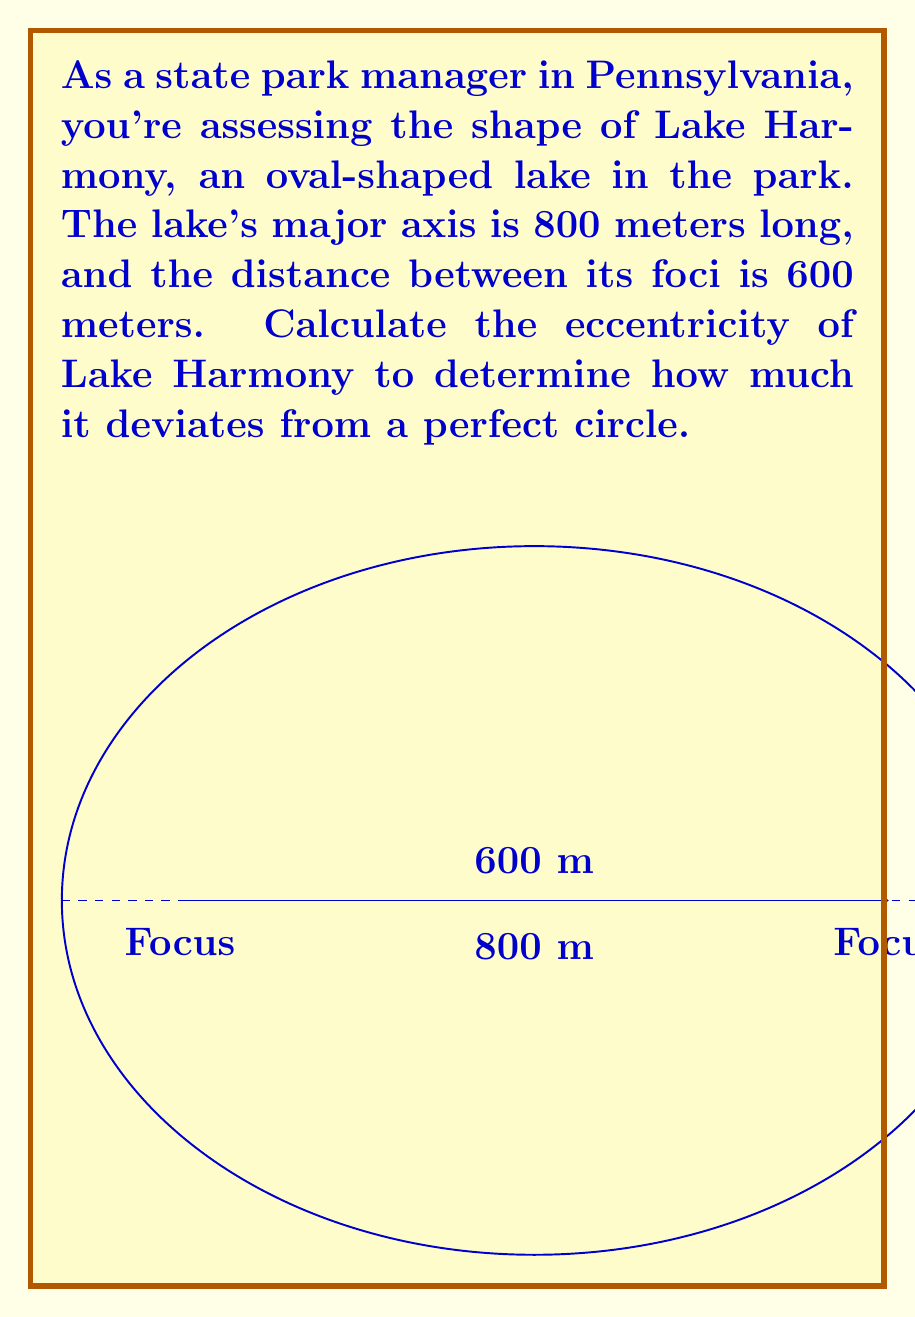What is the answer to this math problem? To find the eccentricity of the oval-shaped lake, we'll follow these steps:

1) The eccentricity (e) of an ellipse is defined as the ratio of the distance between the foci (c) to the length of the semi-major axis (a):

   $$ e = \frac{c}{a} $$

2) We're given:
   - Major axis length = 800 meters
   - Distance between foci = 600 meters

3) The semi-major axis (a) is half of the major axis:
   $$ a = \frac{800}{2} = 400 \text{ meters} $$

4) The distance from the center to a focus (c) is half of the distance between foci:
   $$ c = \frac{600}{2} = 300 \text{ meters} $$

5) Now we can calculate the eccentricity:
   $$ e = \frac{c}{a} = \frac{300}{400} = 0.75 $$

6) The eccentricity is always a value between 0 and 1 for an ellipse. A value of 0 represents a circle, while a value close to 1 represents a very elongated ellipse.
Answer: $e = 0.75$ 